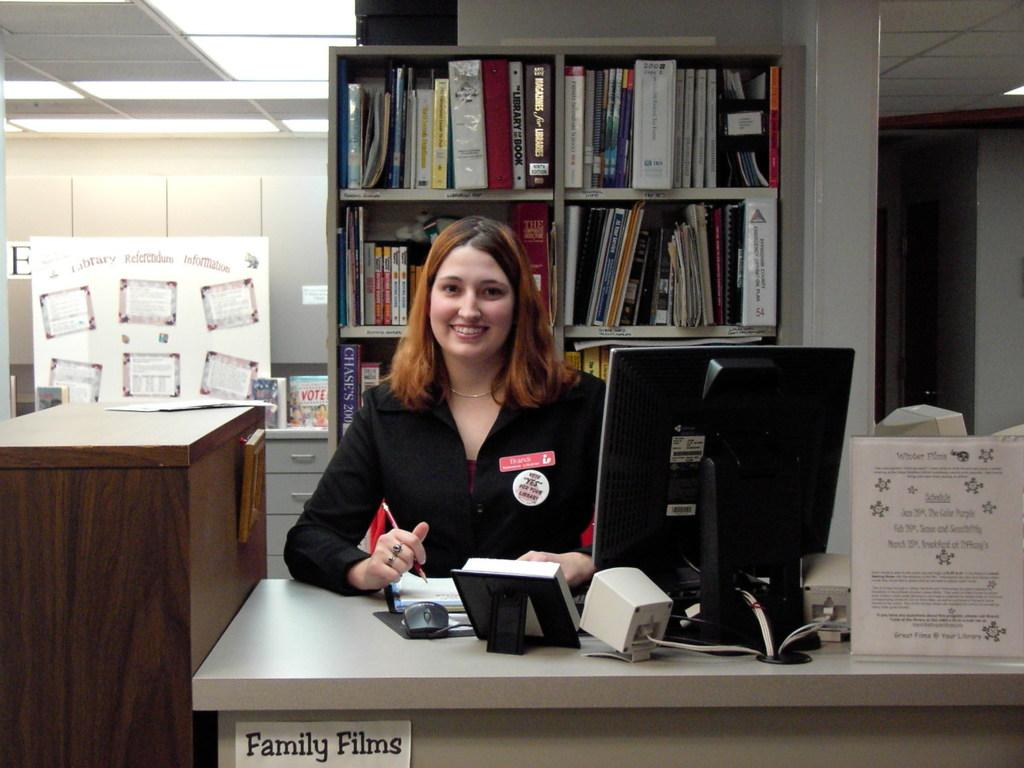<image>
Provide a brief description of the given image. A woman sits at a desk that has a little sign that says "Family Films" on the front of it. 